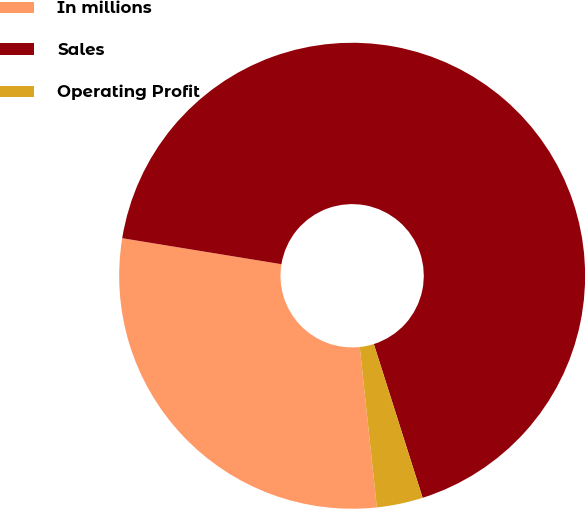<chart> <loc_0><loc_0><loc_500><loc_500><pie_chart><fcel>In millions<fcel>Sales<fcel>Operating Profit<nl><fcel>29.27%<fcel>67.53%<fcel>3.2%<nl></chart> 